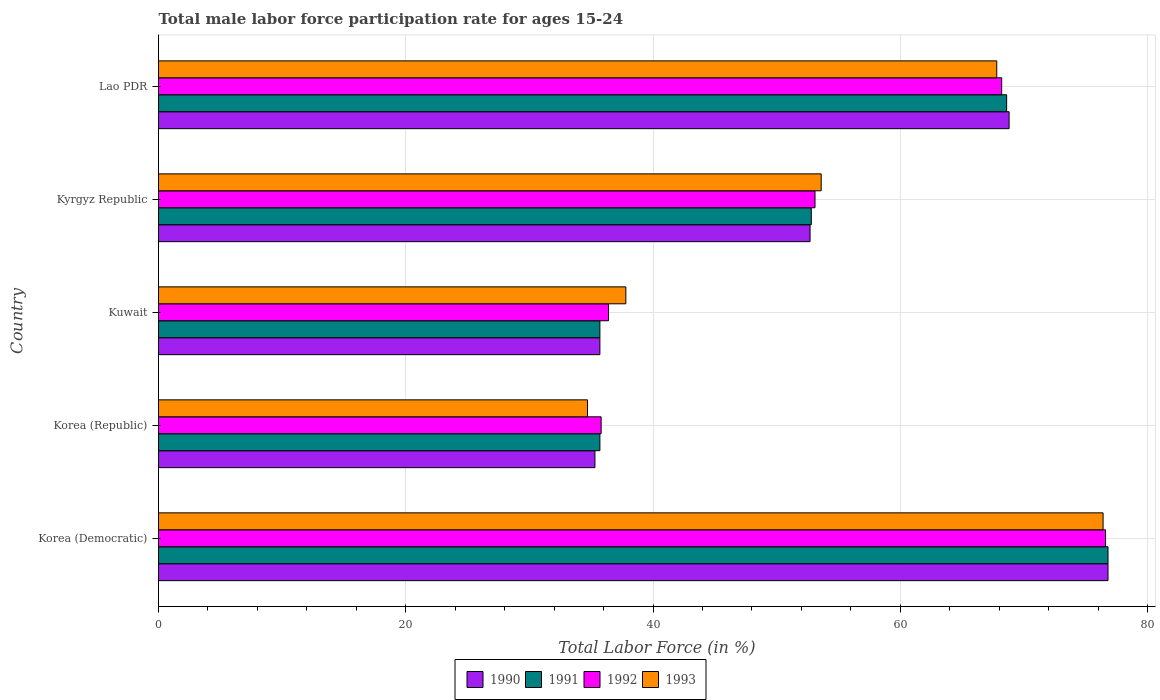How many different coloured bars are there?
Your response must be concise. 4. How many groups of bars are there?
Provide a short and direct response. 5. Are the number of bars on each tick of the Y-axis equal?
Ensure brevity in your answer.  Yes. How many bars are there on the 1st tick from the top?
Ensure brevity in your answer.  4. What is the label of the 3rd group of bars from the top?
Provide a short and direct response. Kuwait. What is the male labor force participation rate in 1993 in Kuwait?
Keep it short and to the point. 37.8. Across all countries, what is the maximum male labor force participation rate in 1993?
Give a very brief answer. 76.4. Across all countries, what is the minimum male labor force participation rate in 1990?
Your response must be concise. 35.3. In which country was the male labor force participation rate in 1990 maximum?
Keep it short and to the point. Korea (Democratic). In which country was the male labor force participation rate in 1991 minimum?
Provide a short and direct response. Korea (Republic). What is the total male labor force participation rate in 1990 in the graph?
Provide a short and direct response. 269.3. What is the difference between the male labor force participation rate in 1990 in Korea (Democratic) and that in Korea (Republic)?
Ensure brevity in your answer.  41.5. What is the difference between the male labor force participation rate in 1992 in Lao PDR and the male labor force participation rate in 1993 in Kyrgyz Republic?
Your answer should be compact. 14.6. What is the average male labor force participation rate in 1991 per country?
Your answer should be compact. 53.92. What is the difference between the male labor force participation rate in 1993 and male labor force participation rate in 1991 in Lao PDR?
Provide a succinct answer. -0.8. In how many countries, is the male labor force participation rate in 1992 greater than 48 %?
Provide a short and direct response. 3. What is the ratio of the male labor force participation rate in 1990 in Korea (Democratic) to that in Lao PDR?
Your answer should be compact. 1.12. What is the difference between the highest and the second highest male labor force participation rate in 1993?
Your answer should be very brief. 8.6. What is the difference between the highest and the lowest male labor force participation rate in 1991?
Offer a terse response. 41.1. In how many countries, is the male labor force participation rate in 1991 greater than the average male labor force participation rate in 1991 taken over all countries?
Offer a very short reply. 2. What does the 2nd bar from the top in Korea (Republic) represents?
Your answer should be very brief. 1992. What does the 3rd bar from the bottom in Korea (Democratic) represents?
Offer a very short reply. 1992. Are the values on the major ticks of X-axis written in scientific E-notation?
Your answer should be very brief. No. Does the graph contain any zero values?
Your answer should be compact. No. Does the graph contain grids?
Your answer should be compact. Yes. How many legend labels are there?
Ensure brevity in your answer.  4. How are the legend labels stacked?
Keep it short and to the point. Horizontal. What is the title of the graph?
Provide a succinct answer. Total male labor force participation rate for ages 15-24. What is the label or title of the X-axis?
Your answer should be compact. Total Labor Force (in %). What is the Total Labor Force (in %) in 1990 in Korea (Democratic)?
Your answer should be very brief. 76.8. What is the Total Labor Force (in %) in 1991 in Korea (Democratic)?
Your answer should be compact. 76.8. What is the Total Labor Force (in %) in 1992 in Korea (Democratic)?
Keep it short and to the point. 76.6. What is the Total Labor Force (in %) of 1993 in Korea (Democratic)?
Your answer should be compact. 76.4. What is the Total Labor Force (in %) in 1990 in Korea (Republic)?
Make the answer very short. 35.3. What is the Total Labor Force (in %) of 1991 in Korea (Republic)?
Ensure brevity in your answer.  35.7. What is the Total Labor Force (in %) of 1992 in Korea (Republic)?
Give a very brief answer. 35.8. What is the Total Labor Force (in %) in 1993 in Korea (Republic)?
Provide a succinct answer. 34.7. What is the Total Labor Force (in %) of 1990 in Kuwait?
Give a very brief answer. 35.7. What is the Total Labor Force (in %) of 1991 in Kuwait?
Keep it short and to the point. 35.7. What is the Total Labor Force (in %) in 1992 in Kuwait?
Your answer should be compact. 36.4. What is the Total Labor Force (in %) in 1993 in Kuwait?
Keep it short and to the point. 37.8. What is the Total Labor Force (in %) in 1990 in Kyrgyz Republic?
Your response must be concise. 52.7. What is the Total Labor Force (in %) of 1991 in Kyrgyz Republic?
Offer a very short reply. 52.8. What is the Total Labor Force (in %) in 1992 in Kyrgyz Republic?
Provide a succinct answer. 53.1. What is the Total Labor Force (in %) in 1993 in Kyrgyz Republic?
Offer a terse response. 53.6. What is the Total Labor Force (in %) in 1990 in Lao PDR?
Provide a short and direct response. 68.8. What is the Total Labor Force (in %) in 1991 in Lao PDR?
Make the answer very short. 68.6. What is the Total Labor Force (in %) in 1992 in Lao PDR?
Provide a succinct answer. 68.2. What is the Total Labor Force (in %) of 1993 in Lao PDR?
Make the answer very short. 67.8. Across all countries, what is the maximum Total Labor Force (in %) of 1990?
Offer a terse response. 76.8. Across all countries, what is the maximum Total Labor Force (in %) in 1991?
Your answer should be very brief. 76.8. Across all countries, what is the maximum Total Labor Force (in %) of 1992?
Provide a short and direct response. 76.6. Across all countries, what is the maximum Total Labor Force (in %) in 1993?
Keep it short and to the point. 76.4. Across all countries, what is the minimum Total Labor Force (in %) in 1990?
Offer a terse response. 35.3. Across all countries, what is the minimum Total Labor Force (in %) of 1991?
Provide a succinct answer. 35.7. Across all countries, what is the minimum Total Labor Force (in %) in 1992?
Make the answer very short. 35.8. Across all countries, what is the minimum Total Labor Force (in %) of 1993?
Make the answer very short. 34.7. What is the total Total Labor Force (in %) in 1990 in the graph?
Your answer should be compact. 269.3. What is the total Total Labor Force (in %) in 1991 in the graph?
Provide a succinct answer. 269.6. What is the total Total Labor Force (in %) in 1992 in the graph?
Ensure brevity in your answer.  270.1. What is the total Total Labor Force (in %) in 1993 in the graph?
Your answer should be compact. 270.3. What is the difference between the Total Labor Force (in %) in 1990 in Korea (Democratic) and that in Korea (Republic)?
Keep it short and to the point. 41.5. What is the difference between the Total Labor Force (in %) in 1991 in Korea (Democratic) and that in Korea (Republic)?
Keep it short and to the point. 41.1. What is the difference between the Total Labor Force (in %) in 1992 in Korea (Democratic) and that in Korea (Republic)?
Offer a terse response. 40.8. What is the difference between the Total Labor Force (in %) of 1993 in Korea (Democratic) and that in Korea (Republic)?
Offer a terse response. 41.7. What is the difference between the Total Labor Force (in %) in 1990 in Korea (Democratic) and that in Kuwait?
Provide a short and direct response. 41.1. What is the difference between the Total Labor Force (in %) of 1991 in Korea (Democratic) and that in Kuwait?
Make the answer very short. 41.1. What is the difference between the Total Labor Force (in %) of 1992 in Korea (Democratic) and that in Kuwait?
Offer a very short reply. 40.2. What is the difference between the Total Labor Force (in %) in 1993 in Korea (Democratic) and that in Kuwait?
Keep it short and to the point. 38.6. What is the difference between the Total Labor Force (in %) of 1990 in Korea (Democratic) and that in Kyrgyz Republic?
Provide a succinct answer. 24.1. What is the difference between the Total Labor Force (in %) of 1991 in Korea (Democratic) and that in Kyrgyz Republic?
Your answer should be compact. 24. What is the difference between the Total Labor Force (in %) of 1992 in Korea (Democratic) and that in Kyrgyz Republic?
Offer a very short reply. 23.5. What is the difference between the Total Labor Force (in %) in 1993 in Korea (Democratic) and that in Kyrgyz Republic?
Give a very brief answer. 22.8. What is the difference between the Total Labor Force (in %) in 1991 in Korea (Democratic) and that in Lao PDR?
Your response must be concise. 8.2. What is the difference between the Total Labor Force (in %) of 1990 in Korea (Republic) and that in Kuwait?
Keep it short and to the point. -0.4. What is the difference between the Total Labor Force (in %) of 1993 in Korea (Republic) and that in Kuwait?
Ensure brevity in your answer.  -3.1. What is the difference between the Total Labor Force (in %) of 1990 in Korea (Republic) and that in Kyrgyz Republic?
Provide a short and direct response. -17.4. What is the difference between the Total Labor Force (in %) in 1991 in Korea (Republic) and that in Kyrgyz Republic?
Keep it short and to the point. -17.1. What is the difference between the Total Labor Force (in %) of 1992 in Korea (Republic) and that in Kyrgyz Republic?
Provide a short and direct response. -17.3. What is the difference between the Total Labor Force (in %) in 1993 in Korea (Republic) and that in Kyrgyz Republic?
Offer a terse response. -18.9. What is the difference between the Total Labor Force (in %) of 1990 in Korea (Republic) and that in Lao PDR?
Make the answer very short. -33.5. What is the difference between the Total Labor Force (in %) in 1991 in Korea (Republic) and that in Lao PDR?
Your response must be concise. -32.9. What is the difference between the Total Labor Force (in %) in 1992 in Korea (Republic) and that in Lao PDR?
Offer a very short reply. -32.4. What is the difference between the Total Labor Force (in %) in 1993 in Korea (Republic) and that in Lao PDR?
Offer a terse response. -33.1. What is the difference between the Total Labor Force (in %) in 1991 in Kuwait and that in Kyrgyz Republic?
Your response must be concise. -17.1. What is the difference between the Total Labor Force (in %) in 1992 in Kuwait and that in Kyrgyz Republic?
Provide a succinct answer. -16.7. What is the difference between the Total Labor Force (in %) in 1993 in Kuwait and that in Kyrgyz Republic?
Offer a very short reply. -15.8. What is the difference between the Total Labor Force (in %) in 1990 in Kuwait and that in Lao PDR?
Ensure brevity in your answer.  -33.1. What is the difference between the Total Labor Force (in %) of 1991 in Kuwait and that in Lao PDR?
Provide a short and direct response. -32.9. What is the difference between the Total Labor Force (in %) of 1992 in Kuwait and that in Lao PDR?
Offer a very short reply. -31.8. What is the difference between the Total Labor Force (in %) of 1990 in Kyrgyz Republic and that in Lao PDR?
Offer a very short reply. -16.1. What is the difference between the Total Labor Force (in %) of 1991 in Kyrgyz Republic and that in Lao PDR?
Provide a short and direct response. -15.8. What is the difference between the Total Labor Force (in %) of 1992 in Kyrgyz Republic and that in Lao PDR?
Make the answer very short. -15.1. What is the difference between the Total Labor Force (in %) in 1993 in Kyrgyz Republic and that in Lao PDR?
Provide a succinct answer. -14.2. What is the difference between the Total Labor Force (in %) of 1990 in Korea (Democratic) and the Total Labor Force (in %) of 1991 in Korea (Republic)?
Keep it short and to the point. 41.1. What is the difference between the Total Labor Force (in %) of 1990 in Korea (Democratic) and the Total Labor Force (in %) of 1992 in Korea (Republic)?
Ensure brevity in your answer.  41. What is the difference between the Total Labor Force (in %) of 1990 in Korea (Democratic) and the Total Labor Force (in %) of 1993 in Korea (Republic)?
Ensure brevity in your answer.  42.1. What is the difference between the Total Labor Force (in %) in 1991 in Korea (Democratic) and the Total Labor Force (in %) in 1993 in Korea (Republic)?
Your answer should be very brief. 42.1. What is the difference between the Total Labor Force (in %) of 1992 in Korea (Democratic) and the Total Labor Force (in %) of 1993 in Korea (Republic)?
Your answer should be very brief. 41.9. What is the difference between the Total Labor Force (in %) in 1990 in Korea (Democratic) and the Total Labor Force (in %) in 1991 in Kuwait?
Provide a succinct answer. 41.1. What is the difference between the Total Labor Force (in %) in 1990 in Korea (Democratic) and the Total Labor Force (in %) in 1992 in Kuwait?
Offer a terse response. 40.4. What is the difference between the Total Labor Force (in %) in 1990 in Korea (Democratic) and the Total Labor Force (in %) in 1993 in Kuwait?
Provide a succinct answer. 39. What is the difference between the Total Labor Force (in %) in 1991 in Korea (Democratic) and the Total Labor Force (in %) in 1992 in Kuwait?
Ensure brevity in your answer.  40.4. What is the difference between the Total Labor Force (in %) in 1991 in Korea (Democratic) and the Total Labor Force (in %) in 1993 in Kuwait?
Give a very brief answer. 39. What is the difference between the Total Labor Force (in %) of 1992 in Korea (Democratic) and the Total Labor Force (in %) of 1993 in Kuwait?
Ensure brevity in your answer.  38.8. What is the difference between the Total Labor Force (in %) of 1990 in Korea (Democratic) and the Total Labor Force (in %) of 1992 in Kyrgyz Republic?
Make the answer very short. 23.7. What is the difference between the Total Labor Force (in %) of 1990 in Korea (Democratic) and the Total Labor Force (in %) of 1993 in Kyrgyz Republic?
Offer a very short reply. 23.2. What is the difference between the Total Labor Force (in %) in 1991 in Korea (Democratic) and the Total Labor Force (in %) in 1992 in Kyrgyz Republic?
Your response must be concise. 23.7. What is the difference between the Total Labor Force (in %) in 1991 in Korea (Democratic) and the Total Labor Force (in %) in 1993 in Kyrgyz Republic?
Your answer should be compact. 23.2. What is the difference between the Total Labor Force (in %) in 1992 in Korea (Democratic) and the Total Labor Force (in %) in 1993 in Kyrgyz Republic?
Offer a very short reply. 23. What is the difference between the Total Labor Force (in %) of 1990 in Korea (Democratic) and the Total Labor Force (in %) of 1991 in Lao PDR?
Provide a succinct answer. 8.2. What is the difference between the Total Labor Force (in %) of 1990 in Korea (Democratic) and the Total Labor Force (in %) of 1993 in Lao PDR?
Make the answer very short. 9. What is the difference between the Total Labor Force (in %) of 1992 in Korea (Democratic) and the Total Labor Force (in %) of 1993 in Lao PDR?
Make the answer very short. 8.8. What is the difference between the Total Labor Force (in %) in 1990 in Korea (Republic) and the Total Labor Force (in %) in 1992 in Kuwait?
Provide a succinct answer. -1.1. What is the difference between the Total Labor Force (in %) of 1991 in Korea (Republic) and the Total Labor Force (in %) of 1992 in Kuwait?
Keep it short and to the point. -0.7. What is the difference between the Total Labor Force (in %) in 1992 in Korea (Republic) and the Total Labor Force (in %) in 1993 in Kuwait?
Keep it short and to the point. -2. What is the difference between the Total Labor Force (in %) of 1990 in Korea (Republic) and the Total Labor Force (in %) of 1991 in Kyrgyz Republic?
Your answer should be very brief. -17.5. What is the difference between the Total Labor Force (in %) of 1990 in Korea (Republic) and the Total Labor Force (in %) of 1992 in Kyrgyz Republic?
Offer a very short reply. -17.8. What is the difference between the Total Labor Force (in %) of 1990 in Korea (Republic) and the Total Labor Force (in %) of 1993 in Kyrgyz Republic?
Your response must be concise. -18.3. What is the difference between the Total Labor Force (in %) in 1991 in Korea (Republic) and the Total Labor Force (in %) in 1992 in Kyrgyz Republic?
Provide a succinct answer. -17.4. What is the difference between the Total Labor Force (in %) of 1991 in Korea (Republic) and the Total Labor Force (in %) of 1993 in Kyrgyz Republic?
Your answer should be compact. -17.9. What is the difference between the Total Labor Force (in %) in 1992 in Korea (Republic) and the Total Labor Force (in %) in 1993 in Kyrgyz Republic?
Offer a terse response. -17.8. What is the difference between the Total Labor Force (in %) in 1990 in Korea (Republic) and the Total Labor Force (in %) in 1991 in Lao PDR?
Your answer should be very brief. -33.3. What is the difference between the Total Labor Force (in %) in 1990 in Korea (Republic) and the Total Labor Force (in %) in 1992 in Lao PDR?
Provide a short and direct response. -32.9. What is the difference between the Total Labor Force (in %) in 1990 in Korea (Republic) and the Total Labor Force (in %) in 1993 in Lao PDR?
Your response must be concise. -32.5. What is the difference between the Total Labor Force (in %) in 1991 in Korea (Republic) and the Total Labor Force (in %) in 1992 in Lao PDR?
Provide a succinct answer. -32.5. What is the difference between the Total Labor Force (in %) of 1991 in Korea (Republic) and the Total Labor Force (in %) of 1993 in Lao PDR?
Your answer should be very brief. -32.1. What is the difference between the Total Labor Force (in %) of 1992 in Korea (Republic) and the Total Labor Force (in %) of 1993 in Lao PDR?
Offer a terse response. -32. What is the difference between the Total Labor Force (in %) in 1990 in Kuwait and the Total Labor Force (in %) in 1991 in Kyrgyz Republic?
Provide a short and direct response. -17.1. What is the difference between the Total Labor Force (in %) of 1990 in Kuwait and the Total Labor Force (in %) of 1992 in Kyrgyz Republic?
Provide a short and direct response. -17.4. What is the difference between the Total Labor Force (in %) in 1990 in Kuwait and the Total Labor Force (in %) in 1993 in Kyrgyz Republic?
Ensure brevity in your answer.  -17.9. What is the difference between the Total Labor Force (in %) of 1991 in Kuwait and the Total Labor Force (in %) of 1992 in Kyrgyz Republic?
Your answer should be very brief. -17.4. What is the difference between the Total Labor Force (in %) in 1991 in Kuwait and the Total Labor Force (in %) in 1993 in Kyrgyz Republic?
Your response must be concise. -17.9. What is the difference between the Total Labor Force (in %) of 1992 in Kuwait and the Total Labor Force (in %) of 1993 in Kyrgyz Republic?
Your response must be concise. -17.2. What is the difference between the Total Labor Force (in %) in 1990 in Kuwait and the Total Labor Force (in %) in 1991 in Lao PDR?
Your answer should be compact. -32.9. What is the difference between the Total Labor Force (in %) in 1990 in Kuwait and the Total Labor Force (in %) in 1992 in Lao PDR?
Your response must be concise. -32.5. What is the difference between the Total Labor Force (in %) in 1990 in Kuwait and the Total Labor Force (in %) in 1993 in Lao PDR?
Make the answer very short. -32.1. What is the difference between the Total Labor Force (in %) in 1991 in Kuwait and the Total Labor Force (in %) in 1992 in Lao PDR?
Offer a terse response. -32.5. What is the difference between the Total Labor Force (in %) of 1991 in Kuwait and the Total Labor Force (in %) of 1993 in Lao PDR?
Provide a succinct answer. -32.1. What is the difference between the Total Labor Force (in %) in 1992 in Kuwait and the Total Labor Force (in %) in 1993 in Lao PDR?
Make the answer very short. -31.4. What is the difference between the Total Labor Force (in %) of 1990 in Kyrgyz Republic and the Total Labor Force (in %) of 1991 in Lao PDR?
Your answer should be compact. -15.9. What is the difference between the Total Labor Force (in %) in 1990 in Kyrgyz Republic and the Total Labor Force (in %) in 1992 in Lao PDR?
Your answer should be compact. -15.5. What is the difference between the Total Labor Force (in %) of 1990 in Kyrgyz Republic and the Total Labor Force (in %) of 1993 in Lao PDR?
Your answer should be very brief. -15.1. What is the difference between the Total Labor Force (in %) of 1991 in Kyrgyz Republic and the Total Labor Force (in %) of 1992 in Lao PDR?
Ensure brevity in your answer.  -15.4. What is the difference between the Total Labor Force (in %) of 1992 in Kyrgyz Republic and the Total Labor Force (in %) of 1993 in Lao PDR?
Offer a terse response. -14.7. What is the average Total Labor Force (in %) of 1990 per country?
Provide a succinct answer. 53.86. What is the average Total Labor Force (in %) in 1991 per country?
Give a very brief answer. 53.92. What is the average Total Labor Force (in %) in 1992 per country?
Offer a terse response. 54.02. What is the average Total Labor Force (in %) in 1993 per country?
Offer a very short reply. 54.06. What is the difference between the Total Labor Force (in %) in 1990 and Total Labor Force (in %) in 1991 in Korea (Democratic)?
Give a very brief answer. 0. What is the difference between the Total Labor Force (in %) in 1990 and Total Labor Force (in %) in 1991 in Korea (Republic)?
Provide a short and direct response. -0.4. What is the difference between the Total Labor Force (in %) in 1991 and Total Labor Force (in %) in 1993 in Korea (Republic)?
Make the answer very short. 1. What is the difference between the Total Labor Force (in %) in 1992 and Total Labor Force (in %) in 1993 in Korea (Republic)?
Provide a succinct answer. 1.1. What is the difference between the Total Labor Force (in %) in 1990 and Total Labor Force (in %) in 1993 in Kuwait?
Offer a very short reply. -2.1. What is the difference between the Total Labor Force (in %) of 1991 and Total Labor Force (in %) of 1992 in Kuwait?
Your answer should be very brief. -0.7. What is the difference between the Total Labor Force (in %) of 1990 and Total Labor Force (in %) of 1993 in Kyrgyz Republic?
Keep it short and to the point. -0.9. What is the difference between the Total Labor Force (in %) in 1991 and Total Labor Force (in %) in 1993 in Kyrgyz Republic?
Your response must be concise. -0.8. What is the difference between the Total Labor Force (in %) in 1990 and Total Labor Force (in %) in 1991 in Lao PDR?
Offer a very short reply. 0.2. What is the difference between the Total Labor Force (in %) in 1991 and Total Labor Force (in %) in 1993 in Lao PDR?
Ensure brevity in your answer.  0.8. What is the ratio of the Total Labor Force (in %) of 1990 in Korea (Democratic) to that in Korea (Republic)?
Offer a very short reply. 2.18. What is the ratio of the Total Labor Force (in %) of 1991 in Korea (Democratic) to that in Korea (Republic)?
Your answer should be compact. 2.15. What is the ratio of the Total Labor Force (in %) of 1992 in Korea (Democratic) to that in Korea (Republic)?
Ensure brevity in your answer.  2.14. What is the ratio of the Total Labor Force (in %) of 1993 in Korea (Democratic) to that in Korea (Republic)?
Your answer should be compact. 2.2. What is the ratio of the Total Labor Force (in %) of 1990 in Korea (Democratic) to that in Kuwait?
Make the answer very short. 2.15. What is the ratio of the Total Labor Force (in %) of 1991 in Korea (Democratic) to that in Kuwait?
Give a very brief answer. 2.15. What is the ratio of the Total Labor Force (in %) of 1992 in Korea (Democratic) to that in Kuwait?
Ensure brevity in your answer.  2.1. What is the ratio of the Total Labor Force (in %) in 1993 in Korea (Democratic) to that in Kuwait?
Keep it short and to the point. 2.02. What is the ratio of the Total Labor Force (in %) of 1990 in Korea (Democratic) to that in Kyrgyz Republic?
Keep it short and to the point. 1.46. What is the ratio of the Total Labor Force (in %) of 1991 in Korea (Democratic) to that in Kyrgyz Republic?
Offer a terse response. 1.45. What is the ratio of the Total Labor Force (in %) in 1992 in Korea (Democratic) to that in Kyrgyz Republic?
Offer a very short reply. 1.44. What is the ratio of the Total Labor Force (in %) of 1993 in Korea (Democratic) to that in Kyrgyz Republic?
Offer a terse response. 1.43. What is the ratio of the Total Labor Force (in %) of 1990 in Korea (Democratic) to that in Lao PDR?
Offer a very short reply. 1.12. What is the ratio of the Total Labor Force (in %) of 1991 in Korea (Democratic) to that in Lao PDR?
Provide a succinct answer. 1.12. What is the ratio of the Total Labor Force (in %) of 1992 in Korea (Democratic) to that in Lao PDR?
Offer a very short reply. 1.12. What is the ratio of the Total Labor Force (in %) of 1993 in Korea (Democratic) to that in Lao PDR?
Make the answer very short. 1.13. What is the ratio of the Total Labor Force (in %) in 1991 in Korea (Republic) to that in Kuwait?
Provide a short and direct response. 1. What is the ratio of the Total Labor Force (in %) of 1992 in Korea (Republic) to that in Kuwait?
Your response must be concise. 0.98. What is the ratio of the Total Labor Force (in %) in 1993 in Korea (Republic) to that in Kuwait?
Your answer should be very brief. 0.92. What is the ratio of the Total Labor Force (in %) in 1990 in Korea (Republic) to that in Kyrgyz Republic?
Ensure brevity in your answer.  0.67. What is the ratio of the Total Labor Force (in %) of 1991 in Korea (Republic) to that in Kyrgyz Republic?
Your answer should be very brief. 0.68. What is the ratio of the Total Labor Force (in %) in 1992 in Korea (Republic) to that in Kyrgyz Republic?
Provide a short and direct response. 0.67. What is the ratio of the Total Labor Force (in %) of 1993 in Korea (Republic) to that in Kyrgyz Republic?
Make the answer very short. 0.65. What is the ratio of the Total Labor Force (in %) of 1990 in Korea (Republic) to that in Lao PDR?
Your response must be concise. 0.51. What is the ratio of the Total Labor Force (in %) of 1991 in Korea (Republic) to that in Lao PDR?
Offer a very short reply. 0.52. What is the ratio of the Total Labor Force (in %) in 1992 in Korea (Republic) to that in Lao PDR?
Your response must be concise. 0.52. What is the ratio of the Total Labor Force (in %) of 1993 in Korea (Republic) to that in Lao PDR?
Make the answer very short. 0.51. What is the ratio of the Total Labor Force (in %) in 1990 in Kuwait to that in Kyrgyz Republic?
Offer a very short reply. 0.68. What is the ratio of the Total Labor Force (in %) in 1991 in Kuwait to that in Kyrgyz Republic?
Your response must be concise. 0.68. What is the ratio of the Total Labor Force (in %) of 1992 in Kuwait to that in Kyrgyz Republic?
Provide a short and direct response. 0.69. What is the ratio of the Total Labor Force (in %) in 1993 in Kuwait to that in Kyrgyz Republic?
Your response must be concise. 0.71. What is the ratio of the Total Labor Force (in %) of 1990 in Kuwait to that in Lao PDR?
Provide a short and direct response. 0.52. What is the ratio of the Total Labor Force (in %) in 1991 in Kuwait to that in Lao PDR?
Ensure brevity in your answer.  0.52. What is the ratio of the Total Labor Force (in %) in 1992 in Kuwait to that in Lao PDR?
Keep it short and to the point. 0.53. What is the ratio of the Total Labor Force (in %) of 1993 in Kuwait to that in Lao PDR?
Give a very brief answer. 0.56. What is the ratio of the Total Labor Force (in %) in 1990 in Kyrgyz Republic to that in Lao PDR?
Make the answer very short. 0.77. What is the ratio of the Total Labor Force (in %) in 1991 in Kyrgyz Republic to that in Lao PDR?
Your response must be concise. 0.77. What is the ratio of the Total Labor Force (in %) of 1992 in Kyrgyz Republic to that in Lao PDR?
Your answer should be very brief. 0.78. What is the ratio of the Total Labor Force (in %) in 1993 in Kyrgyz Republic to that in Lao PDR?
Your answer should be very brief. 0.79. What is the difference between the highest and the second highest Total Labor Force (in %) of 1992?
Make the answer very short. 8.4. What is the difference between the highest and the lowest Total Labor Force (in %) in 1990?
Your answer should be compact. 41.5. What is the difference between the highest and the lowest Total Labor Force (in %) in 1991?
Ensure brevity in your answer.  41.1. What is the difference between the highest and the lowest Total Labor Force (in %) in 1992?
Give a very brief answer. 40.8. What is the difference between the highest and the lowest Total Labor Force (in %) in 1993?
Provide a short and direct response. 41.7. 